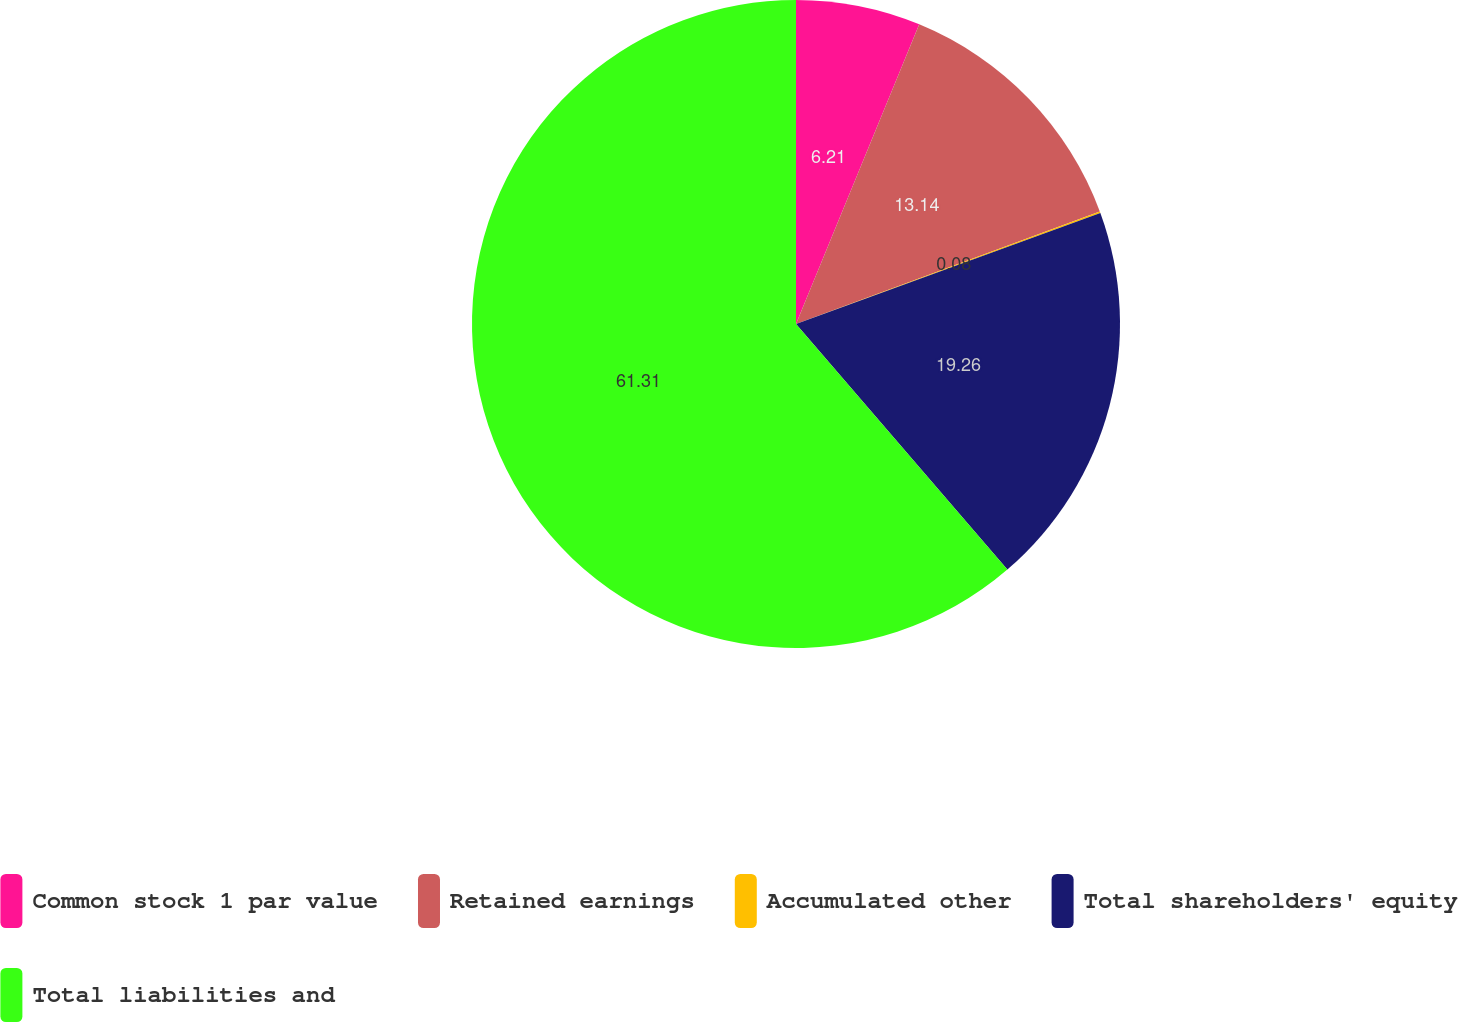Convert chart. <chart><loc_0><loc_0><loc_500><loc_500><pie_chart><fcel>Common stock 1 par value<fcel>Retained earnings<fcel>Accumulated other<fcel>Total shareholders' equity<fcel>Total liabilities and<nl><fcel>6.21%<fcel>13.14%<fcel>0.08%<fcel>19.26%<fcel>61.31%<nl></chart> 